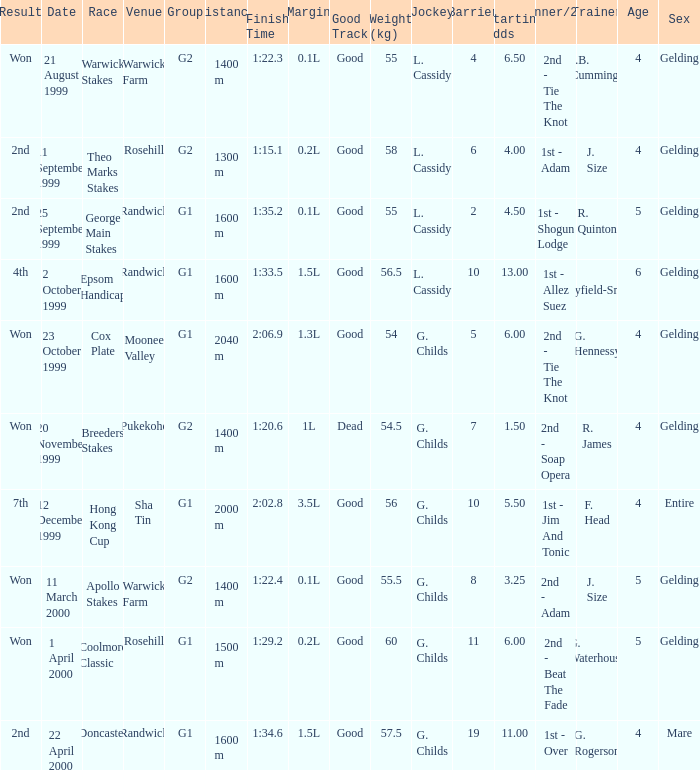How man teams had a total weight of 57.5? 1.0. 